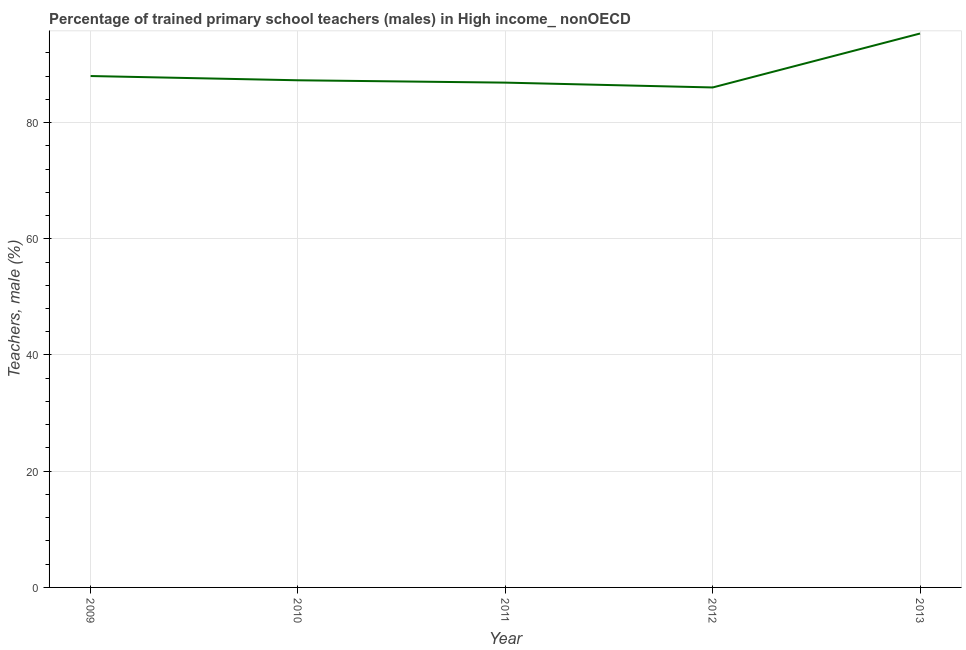What is the percentage of trained male teachers in 2010?
Keep it short and to the point. 87.27. Across all years, what is the maximum percentage of trained male teachers?
Your answer should be very brief. 95.32. Across all years, what is the minimum percentage of trained male teachers?
Offer a terse response. 86.04. In which year was the percentage of trained male teachers maximum?
Ensure brevity in your answer.  2013. What is the sum of the percentage of trained male teachers?
Keep it short and to the point. 443.51. What is the difference between the percentage of trained male teachers in 2009 and 2010?
Make the answer very short. 0.73. What is the average percentage of trained male teachers per year?
Provide a short and direct response. 88.7. What is the median percentage of trained male teachers?
Provide a short and direct response. 87.27. In how many years, is the percentage of trained male teachers greater than 48 %?
Your answer should be compact. 5. Do a majority of the years between 2013 and 2010 (inclusive) have percentage of trained male teachers greater than 40 %?
Offer a very short reply. Yes. What is the ratio of the percentage of trained male teachers in 2012 to that in 2013?
Your response must be concise. 0.9. Is the percentage of trained male teachers in 2009 less than that in 2012?
Ensure brevity in your answer.  No. Is the difference between the percentage of trained male teachers in 2012 and 2013 greater than the difference between any two years?
Keep it short and to the point. Yes. What is the difference between the highest and the second highest percentage of trained male teachers?
Make the answer very short. 7.32. Is the sum of the percentage of trained male teachers in 2010 and 2012 greater than the maximum percentage of trained male teachers across all years?
Ensure brevity in your answer.  Yes. What is the difference between the highest and the lowest percentage of trained male teachers?
Keep it short and to the point. 9.28. Does the percentage of trained male teachers monotonically increase over the years?
Offer a very short reply. No. Are the values on the major ticks of Y-axis written in scientific E-notation?
Your answer should be compact. No. Does the graph contain any zero values?
Your answer should be very brief. No. What is the title of the graph?
Provide a succinct answer. Percentage of trained primary school teachers (males) in High income_ nonOECD. What is the label or title of the Y-axis?
Ensure brevity in your answer.  Teachers, male (%). What is the Teachers, male (%) of 2009?
Offer a terse response. 88.01. What is the Teachers, male (%) of 2010?
Offer a terse response. 87.27. What is the Teachers, male (%) in 2011?
Your response must be concise. 86.87. What is the Teachers, male (%) of 2012?
Make the answer very short. 86.04. What is the Teachers, male (%) in 2013?
Provide a succinct answer. 95.32. What is the difference between the Teachers, male (%) in 2009 and 2010?
Give a very brief answer. 0.73. What is the difference between the Teachers, male (%) in 2009 and 2011?
Make the answer very short. 1.13. What is the difference between the Teachers, male (%) in 2009 and 2012?
Keep it short and to the point. 1.97. What is the difference between the Teachers, male (%) in 2009 and 2013?
Your answer should be compact. -7.32. What is the difference between the Teachers, male (%) in 2010 and 2011?
Make the answer very short. 0.4. What is the difference between the Teachers, male (%) in 2010 and 2012?
Provide a short and direct response. 1.23. What is the difference between the Teachers, male (%) in 2010 and 2013?
Make the answer very short. -8.05. What is the difference between the Teachers, male (%) in 2011 and 2012?
Provide a succinct answer. 0.83. What is the difference between the Teachers, male (%) in 2011 and 2013?
Give a very brief answer. -8.45. What is the difference between the Teachers, male (%) in 2012 and 2013?
Keep it short and to the point. -9.28. What is the ratio of the Teachers, male (%) in 2009 to that in 2013?
Your answer should be very brief. 0.92. What is the ratio of the Teachers, male (%) in 2010 to that in 2011?
Your answer should be very brief. 1. What is the ratio of the Teachers, male (%) in 2010 to that in 2012?
Give a very brief answer. 1.01. What is the ratio of the Teachers, male (%) in 2010 to that in 2013?
Make the answer very short. 0.92. What is the ratio of the Teachers, male (%) in 2011 to that in 2012?
Your answer should be very brief. 1.01. What is the ratio of the Teachers, male (%) in 2011 to that in 2013?
Offer a very short reply. 0.91. What is the ratio of the Teachers, male (%) in 2012 to that in 2013?
Provide a succinct answer. 0.9. 